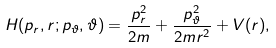Convert formula to latex. <formula><loc_0><loc_0><loc_500><loc_500>H ( p _ { r } , r ; p _ { \vartheta } , \vartheta ) = \frac { p _ { r } ^ { 2 } } { 2 m } + \frac { p _ { \vartheta } ^ { 2 } } { 2 m r ^ { 2 } } + V ( r ) ,</formula> 